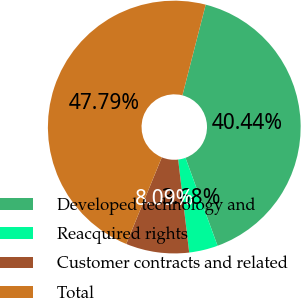<chart> <loc_0><loc_0><loc_500><loc_500><pie_chart><fcel>Developed technology and<fcel>Reacquired rights<fcel>Customer contracts and related<fcel>Total<nl><fcel>40.44%<fcel>3.68%<fcel>8.09%<fcel>47.79%<nl></chart> 